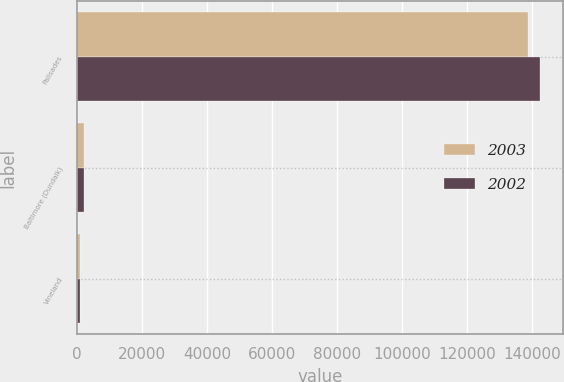Convert chart to OTSL. <chart><loc_0><loc_0><loc_500><loc_500><stacked_bar_chart><ecel><fcel>Palisades<fcel>Baltimore (Dundalk)<fcel>Vineland<nl><fcel>2003<fcel>138629<fcel>2167<fcel>908<nl><fcel>2002<fcel>142333<fcel>2050<fcel>978<nl></chart> 